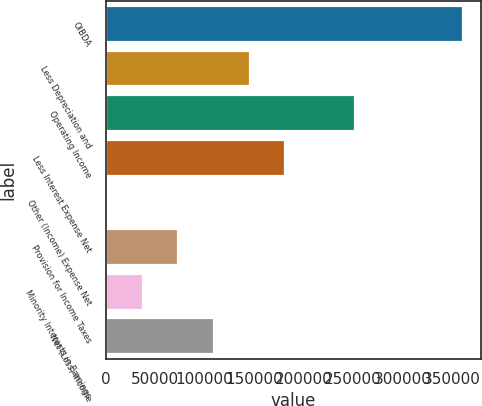<chart> <loc_0><loc_0><loc_500><loc_500><bar_chart><fcel>OIBDA<fcel>Less Depreciation and<fcel>Operating Income<fcel>Less Interest Expense Net<fcel>Other (Income) Expense Net<fcel>Provision for Income Taxes<fcel>Minority Interests in Earnings<fcel>Net (Loss) Income<nl><fcel>361578<fcel>145492<fcel>252586<fcel>181506<fcel>1435<fcel>73463.6<fcel>37449.3<fcel>109478<nl></chart> 